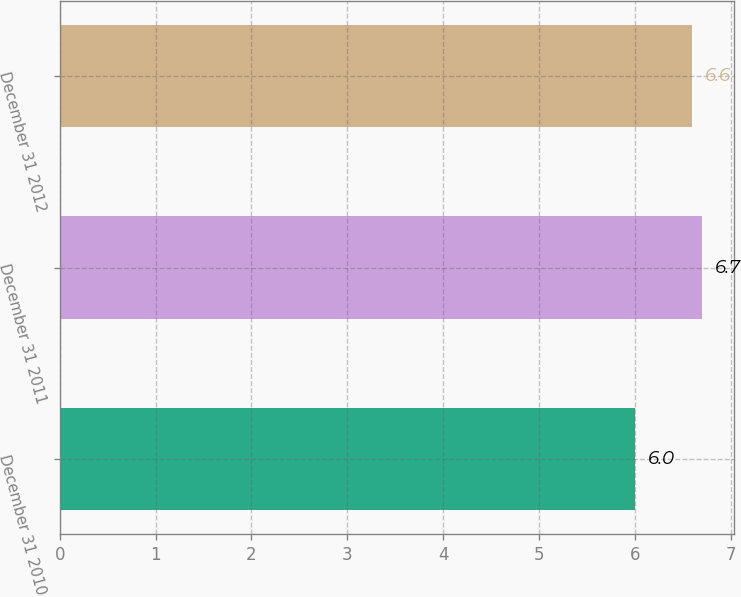<chart> <loc_0><loc_0><loc_500><loc_500><bar_chart><fcel>December 31 2010<fcel>December 31 2011<fcel>December 31 2012<nl><fcel>6<fcel>6.7<fcel>6.6<nl></chart> 